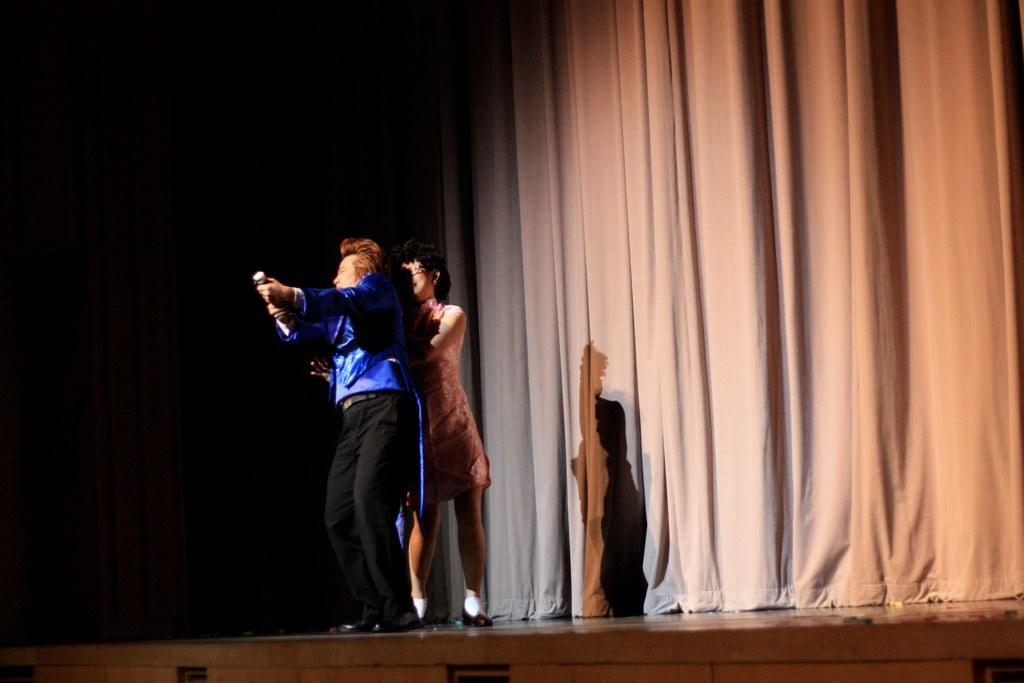How many people are in the image? There are two persons standing in the image. Can you describe the clothing of the person in front? The person in front is wearing a blue shirt and black pants. What color is the dress worn by the person at the back? The person at the back is wearing a peach-colored dress. What color is the curtain in the image? The curtain in the image is cream-colored. What historical event is being commemorated by the persons in the image? There is no indication of a historical event or commemoration in the image. 